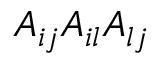Convert formula to latex. <formula><loc_0><loc_0><loc_500><loc_500>A _ { i j } A _ { i l } A _ { l j }</formula> 